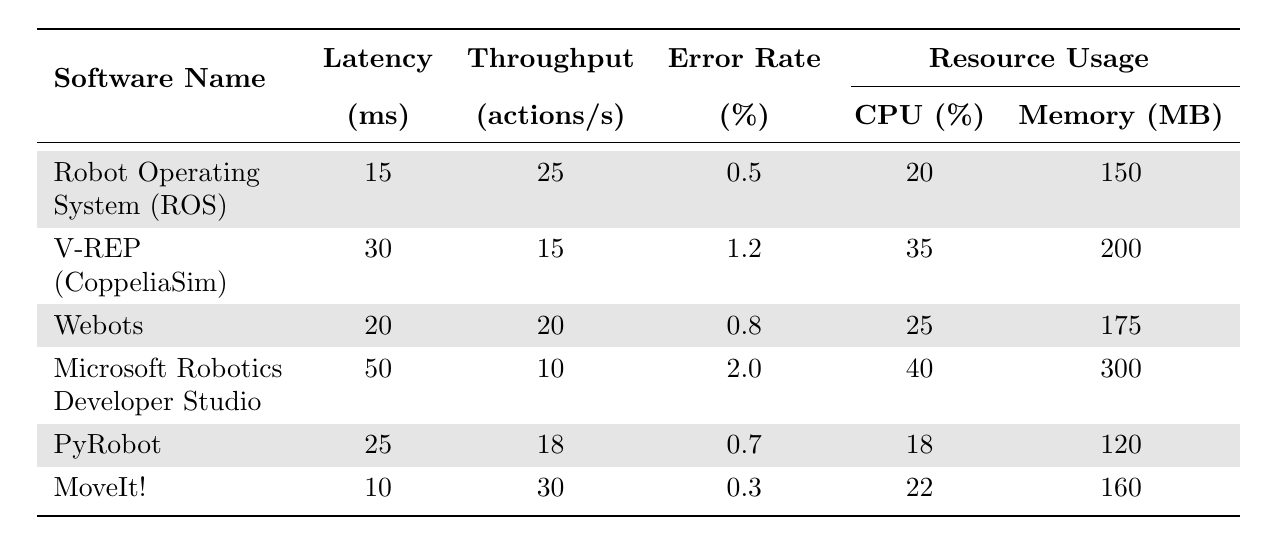What is the latency of MoveIt!? The latency is directly provided in the table next to MoveIt!, which is 10 ms.
Answer: 10 ms Which software has the highest error rate percentage? By examining the error rate column in the table, Microsoft Robotics Developer Studio has the highest value of 2.0%.
Answer: Microsoft Robotics Developer Studio What is the average latency of all the software listed? To find the average latency, sum the latencies: 15 + 30 + 20 + 50 + 25 + 10 = 150 ms. There are 6 software entries, so divide 150 ms by 6 which equals 25 ms.
Answer: 25 ms Is the throughput of V-REP greater than that of Webots? V-REP has a throughput of 15 actions per second, while Webots has 20 actions per second. Since 15 is less than 20, the statement is false.
Answer: No What is the total CPU resource usage for all listed software? Add the CPU usage percentages together: 20 + 35 + 25 + 40 + 18 + 22 = 160%.
Answer: 160% Which software has the lowest resource usage in memory? By checking the memory usage column, PyRobot has the lowest resource usage listed, which is 120 MB.
Answer: PyRobot If you combine the latency of ROS and PyRobot, what is the result? The latency for ROS is 15 ms and for PyRobot is 25 ms. Summing these gives 15 + 25 = 40 ms.
Answer: 40 ms Is there a software that has a lower error rate than 0.5%? The smallest error rate listed is for MoveIt! at 0.3%, which is below 0.5%. Therefore, yes, there is at least one software meeting the criteria.
Answer: Yes What is the difference in throughput between MoveIt! and Microsoft Robotics Developer Studio? MoveIt! has a throughput of 30 actions per second and Microsoft Robotics Developer Studio has 10 actions per second. The difference is 30 - 10 = 20 actions per second.
Answer: 20 actions per second Which software has the highest throughput, and what is its value? Checking the throughput column, MoveIt! has the highest throughput at 30 actions per second.
Answer: MoveIt!; 30 actions per second 